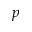Convert formula to latex. <formula><loc_0><loc_0><loc_500><loc_500>p</formula> 